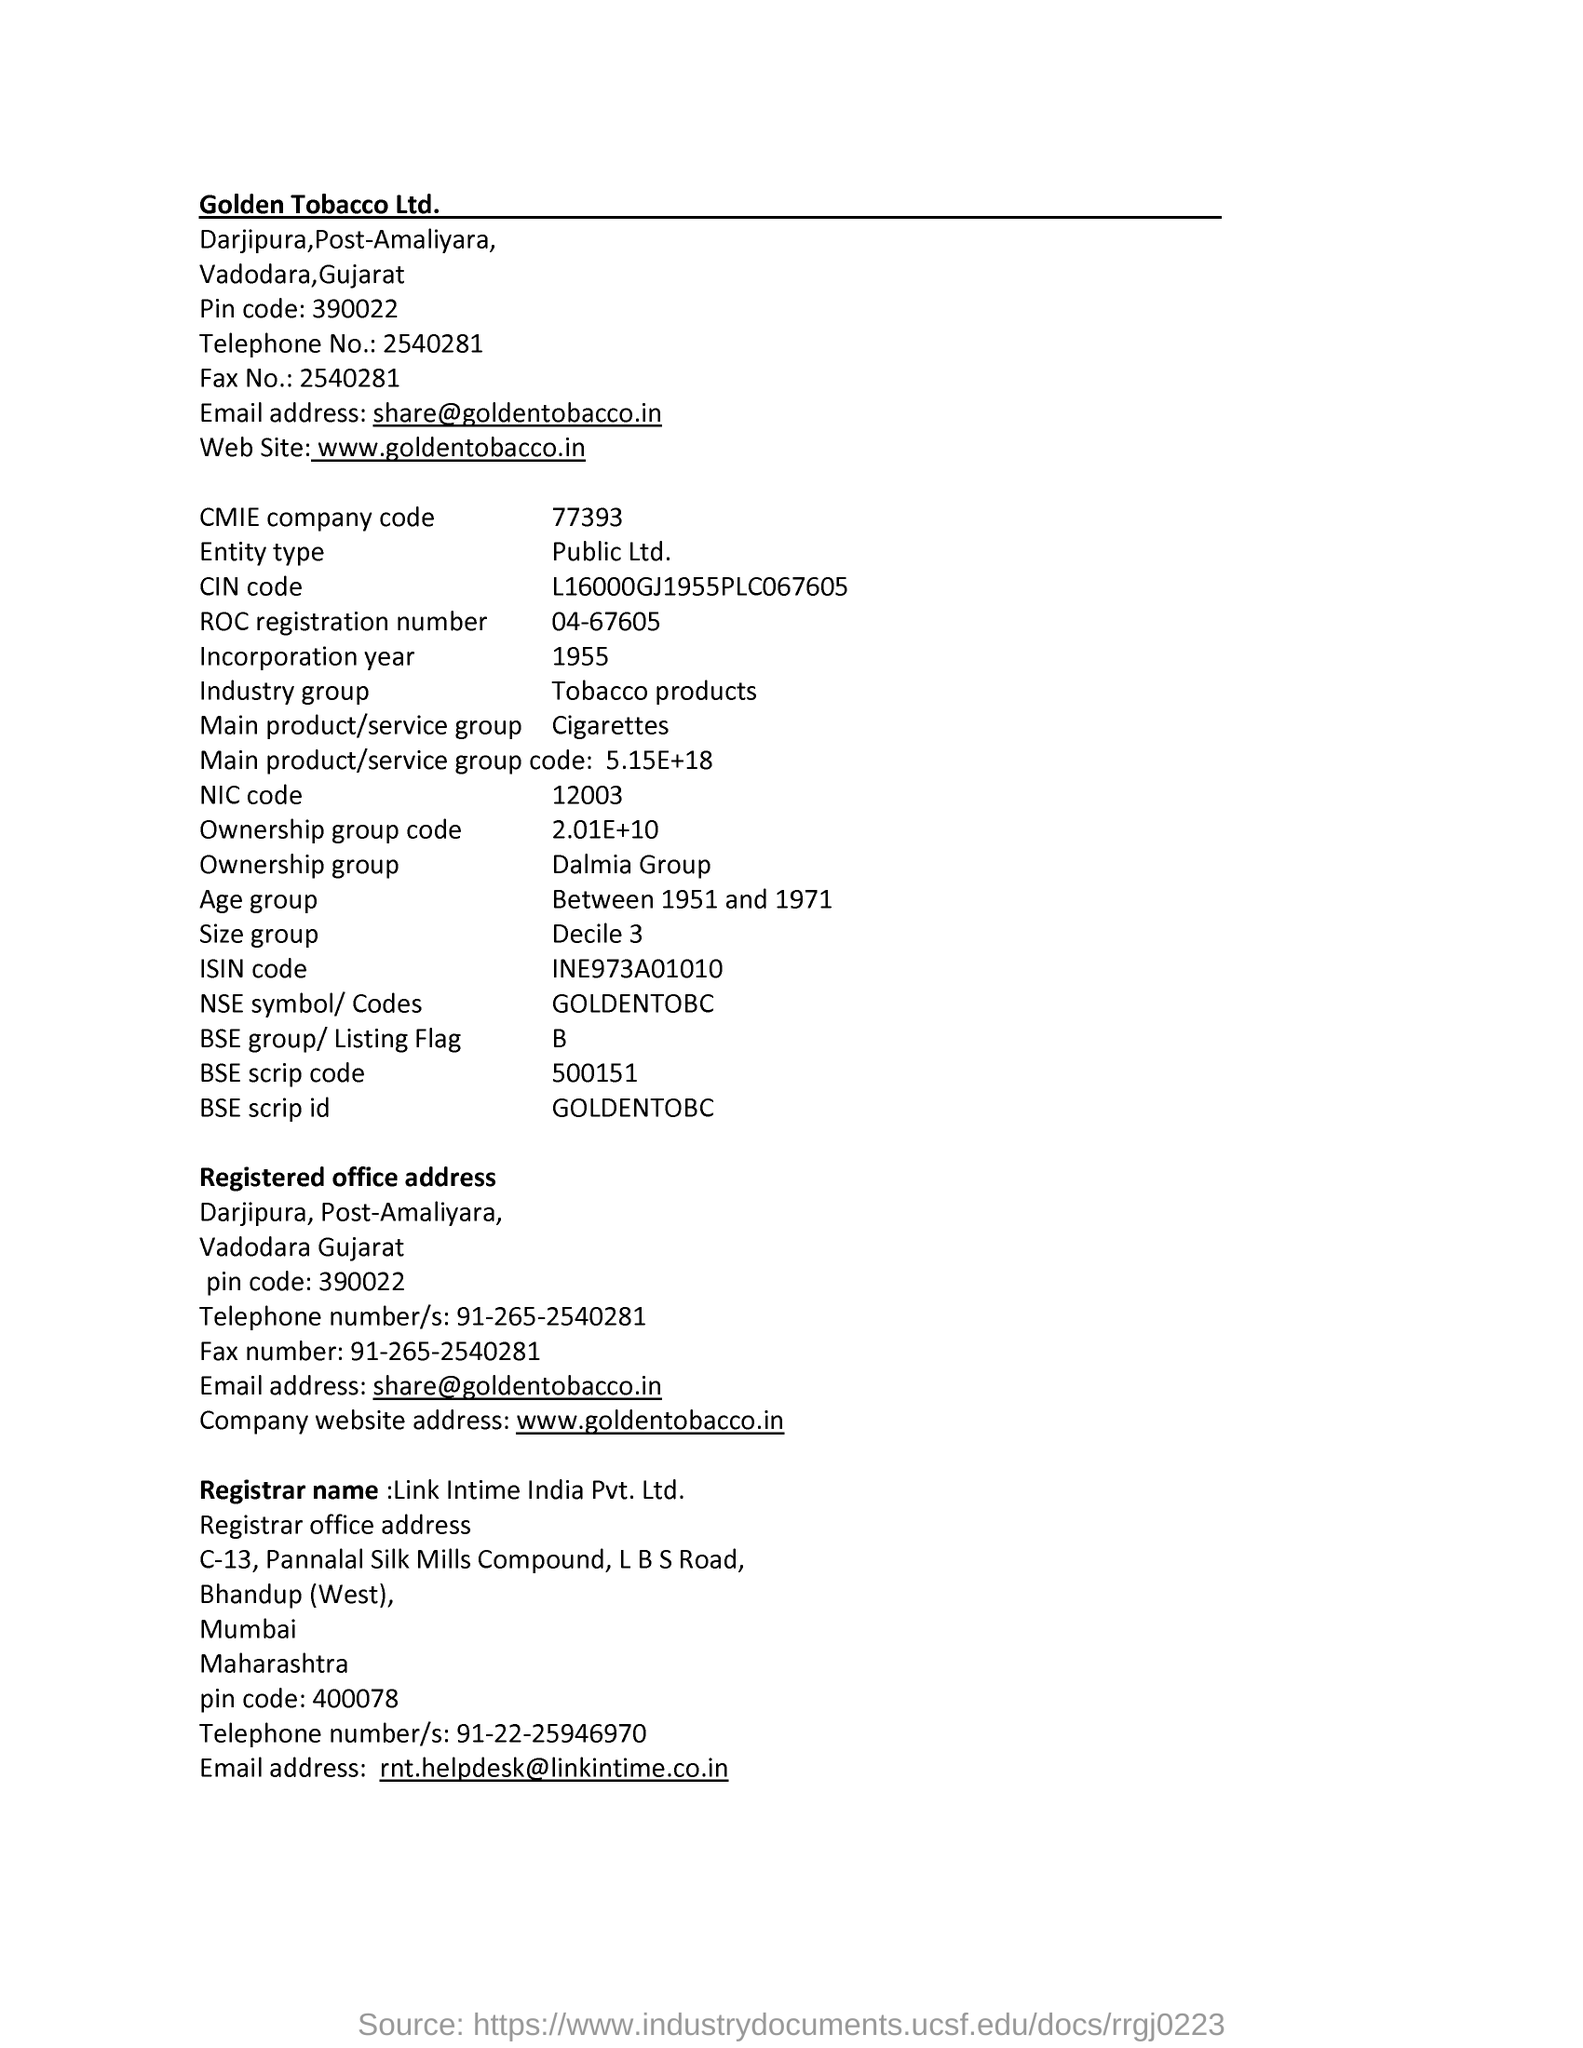Mention a couple of crucial points in this snapshot. What is the ROC registration number? 04-67605..." is a question asking for the ROC registration number. The CMIE company code is 77393. The ownership group code is a numerical value of 2.01E+10, which represents the ownership group to which an asset belongs. The NIC Code is 12003. The BSE group is an acronym for Bombay Stock Exchange, a major stock exchange located in Mumbai, India. 